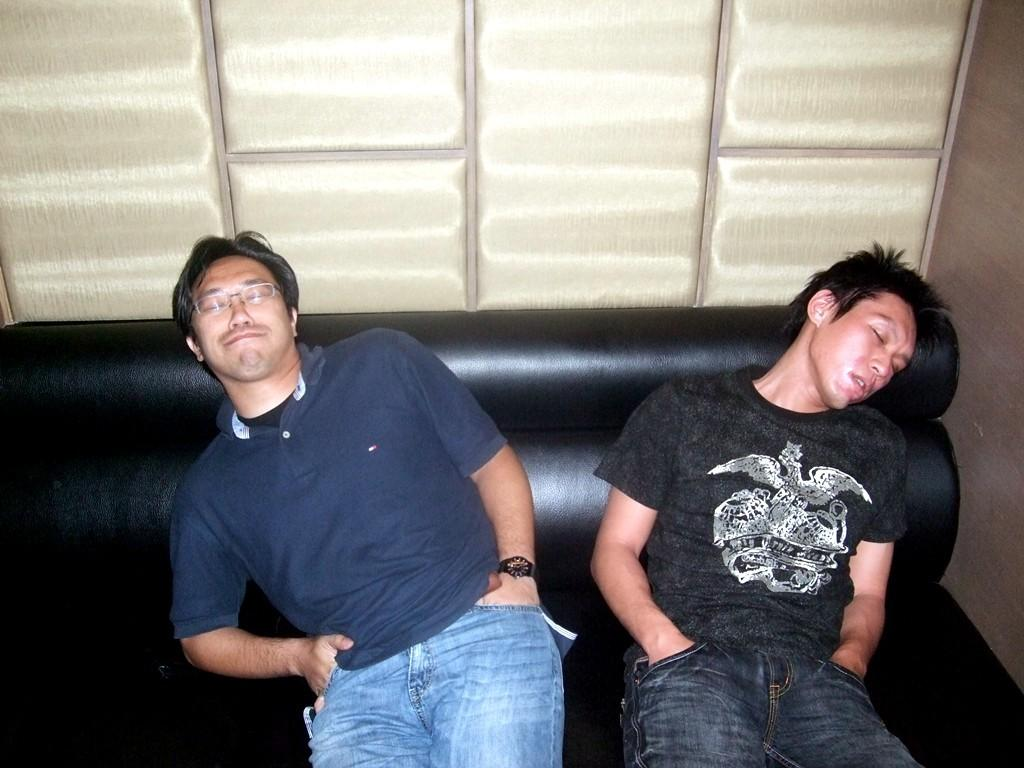How many people are in the image? There are two persons in the image. What are the persons doing in the image? The persons are sleeping on a sofa. What can be seen in the background of the image? There is a wall visible in the background of the image. What type of fight is taking place in the image? There is no fight present in the image; the persons are sleeping on a sofa. What is the income of the persons in the image? There is no information about the income of the persons in the image. 